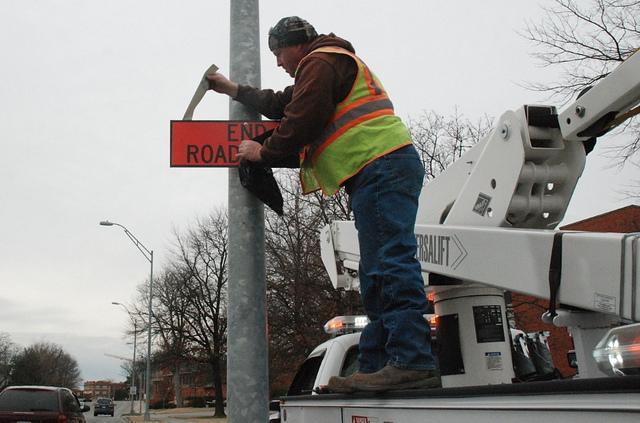How many people in the picture?
Give a very brief answer. 1. How many cars are visible?
Give a very brief answer. 2. 